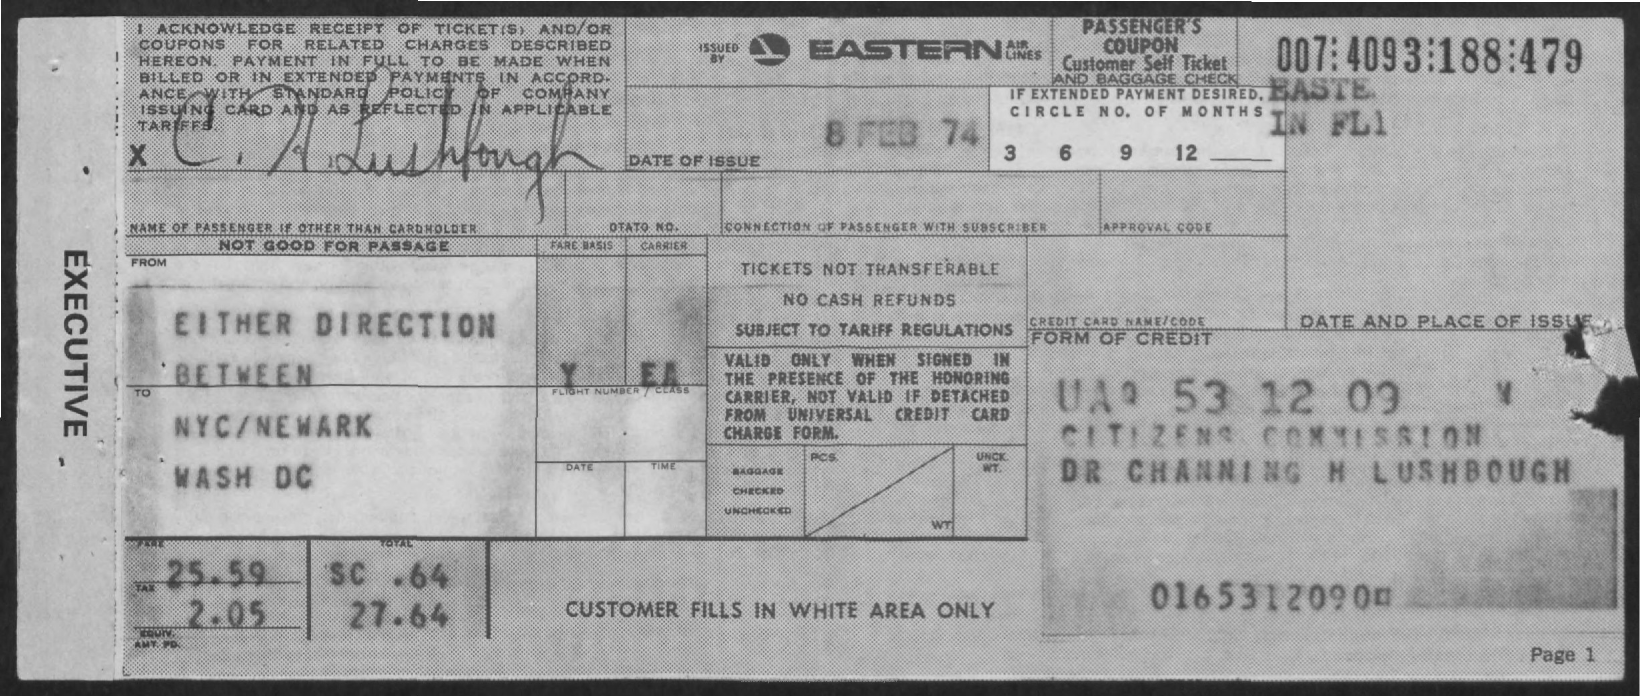Outline some significant characteristics in this image. The given form mentions a tax amount of 2.05... The date of issue mentioned on the given form is February 8, 1974. The amount of fare mentioned in the given form is 25.59. The total amount mentioned in the given form is 27.64. The form is issued by Eastern Airlines. 